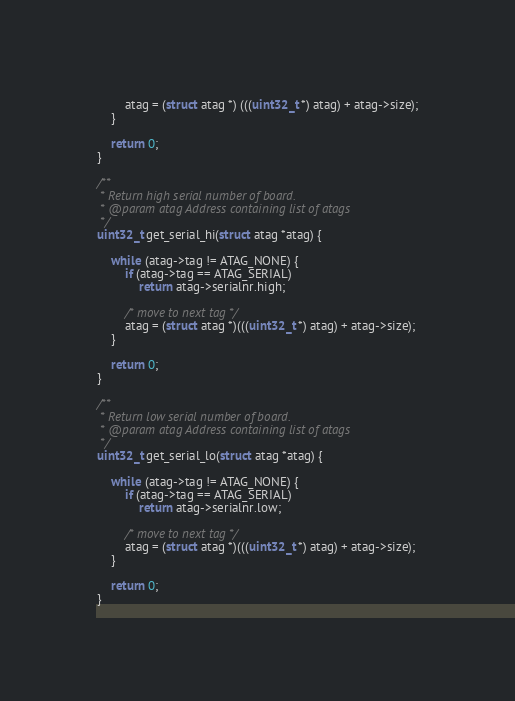<code> <loc_0><loc_0><loc_500><loc_500><_C_>		atag = (struct atag *) (((uint32_t *) atag) + atag->size);
	}

	return 0;
}

/**
 * Return high serial number of board.
 * @param atag Address containing list of atags
 */
uint32_t get_serial_hi(struct atag *atag) {

	while (atag->tag != ATAG_NONE) {
		if (atag->tag == ATAG_SERIAL)
			return atag->serialnr.high;

		/* move to next tag */
		atag = (struct atag *)(((uint32_t *) atag) + atag->size);
	}

	return 0;
}

/**
 * Return low serial number of board.
 * @param atag Address containing list of atags
 */
uint32_t get_serial_lo(struct atag *atag) {

	while (atag->tag != ATAG_NONE) {
		if (atag->tag == ATAG_SERIAL)
			return atag->serialnr.low;

		/* move to next tag */
		atag = (struct atag *)(((uint32_t *) atag) + atag->size);
	}

	return 0;
}
</code> 